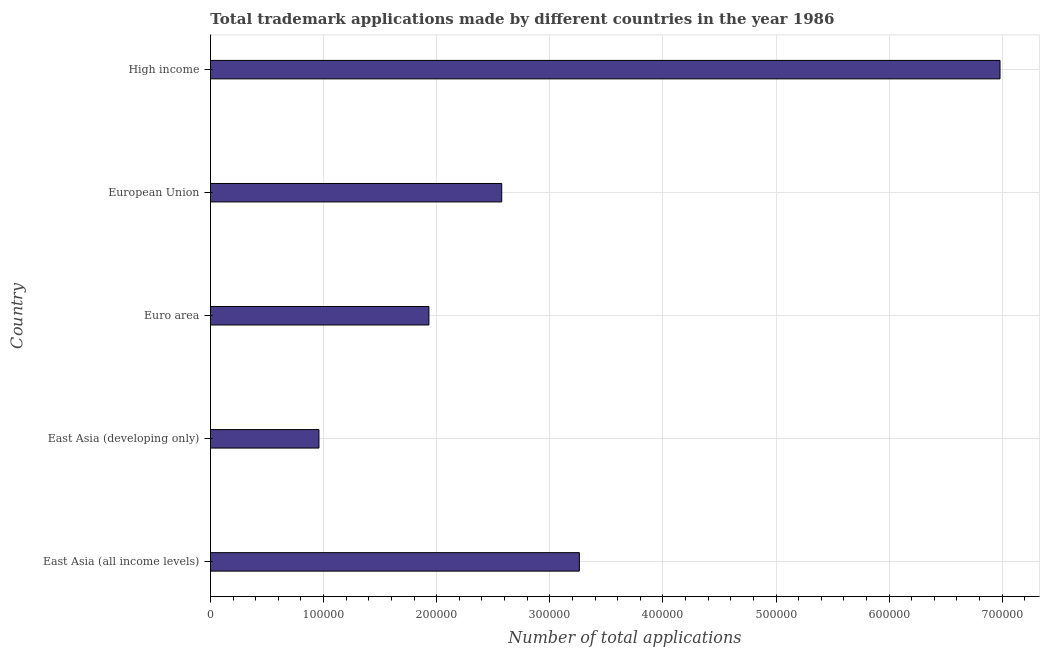Does the graph contain any zero values?
Offer a very short reply. No. What is the title of the graph?
Provide a succinct answer. Total trademark applications made by different countries in the year 1986. What is the label or title of the X-axis?
Your answer should be compact. Number of total applications. What is the label or title of the Y-axis?
Your response must be concise. Country. What is the number of trademark applications in European Union?
Make the answer very short. 2.58e+05. Across all countries, what is the maximum number of trademark applications?
Make the answer very short. 6.98e+05. Across all countries, what is the minimum number of trademark applications?
Give a very brief answer. 9.59e+04. In which country was the number of trademark applications maximum?
Your answer should be compact. High income. In which country was the number of trademark applications minimum?
Keep it short and to the point. East Asia (developing only). What is the sum of the number of trademark applications?
Keep it short and to the point. 1.57e+06. What is the difference between the number of trademark applications in Euro area and European Union?
Your response must be concise. -6.44e+04. What is the average number of trademark applications per country?
Your answer should be compact. 3.14e+05. What is the median number of trademark applications?
Keep it short and to the point. 2.58e+05. In how many countries, is the number of trademark applications greater than 260000 ?
Give a very brief answer. 2. What is the ratio of the number of trademark applications in East Asia (all income levels) to that in Euro area?
Offer a very short reply. 1.69. Is the number of trademark applications in East Asia (developing only) less than that in Euro area?
Provide a short and direct response. Yes. Is the difference between the number of trademark applications in East Asia (all income levels) and European Union greater than the difference between any two countries?
Your answer should be very brief. No. What is the difference between the highest and the second highest number of trademark applications?
Your response must be concise. 3.72e+05. What is the difference between the highest and the lowest number of trademark applications?
Give a very brief answer. 6.02e+05. What is the difference between two consecutive major ticks on the X-axis?
Your answer should be compact. 1.00e+05. What is the Number of total applications in East Asia (all income levels)?
Your answer should be compact. 3.26e+05. What is the Number of total applications in East Asia (developing only)?
Provide a succinct answer. 9.59e+04. What is the Number of total applications in Euro area?
Give a very brief answer. 1.93e+05. What is the Number of total applications in European Union?
Provide a short and direct response. 2.58e+05. What is the Number of total applications in High income?
Provide a short and direct response. 6.98e+05. What is the difference between the Number of total applications in East Asia (all income levels) and East Asia (developing only)?
Make the answer very short. 2.30e+05. What is the difference between the Number of total applications in East Asia (all income levels) and Euro area?
Offer a terse response. 1.33e+05. What is the difference between the Number of total applications in East Asia (all income levels) and European Union?
Provide a short and direct response. 6.87e+04. What is the difference between the Number of total applications in East Asia (all income levels) and High income?
Your response must be concise. -3.72e+05. What is the difference between the Number of total applications in East Asia (developing only) and Euro area?
Offer a very short reply. -9.72e+04. What is the difference between the Number of total applications in East Asia (developing only) and European Union?
Keep it short and to the point. -1.62e+05. What is the difference between the Number of total applications in East Asia (developing only) and High income?
Make the answer very short. -6.02e+05. What is the difference between the Number of total applications in Euro area and European Union?
Your response must be concise. -6.44e+04. What is the difference between the Number of total applications in Euro area and High income?
Provide a succinct answer. -5.05e+05. What is the difference between the Number of total applications in European Union and High income?
Your answer should be compact. -4.41e+05. What is the ratio of the Number of total applications in East Asia (all income levels) to that in East Asia (developing only)?
Your answer should be compact. 3.4. What is the ratio of the Number of total applications in East Asia (all income levels) to that in Euro area?
Offer a terse response. 1.69. What is the ratio of the Number of total applications in East Asia (all income levels) to that in European Union?
Offer a terse response. 1.27. What is the ratio of the Number of total applications in East Asia (all income levels) to that in High income?
Your response must be concise. 0.47. What is the ratio of the Number of total applications in East Asia (developing only) to that in Euro area?
Make the answer very short. 0.5. What is the ratio of the Number of total applications in East Asia (developing only) to that in European Union?
Keep it short and to the point. 0.37. What is the ratio of the Number of total applications in East Asia (developing only) to that in High income?
Your answer should be very brief. 0.14. What is the ratio of the Number of total applications in Euro area to that in European Union?
Keep it short and to the point. 0.75. What is the ratio of the Number of total applications in Euro area to that in High income?
Provide a short and direct response. 0.28. What is the ratio of the Number of total applications in European Union to that in High income?
Offer a terse response. 0.37. 